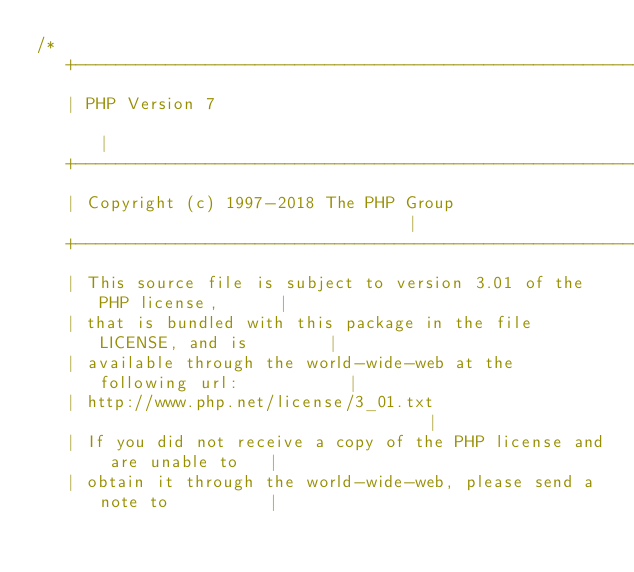Convert code to text. <code><loc_0><loc_0><loc_500><loc_500><_C_>/*
   +----------------------------------------------------------------------+
   | PHP Version 7                                                        |
   +----------------------------------------------------------------------+
   | Copyright (c) 1997-2018 The PHP Group                                |
   +----------------------------------------------------------------------+
   | This source file is subject to version 3.01 of the PHP license,      |
   | that is bundled with this package in the file LICENSE, and is        |
   | available through the world-wide-web at the following url:           |
   | http://www.php.net/license/3_01.txt                                  |
   | If you did not receive a copy of the PHP license and are unable to   |
   | obtain it through the world-wide-web, please send a note to          |</code> 